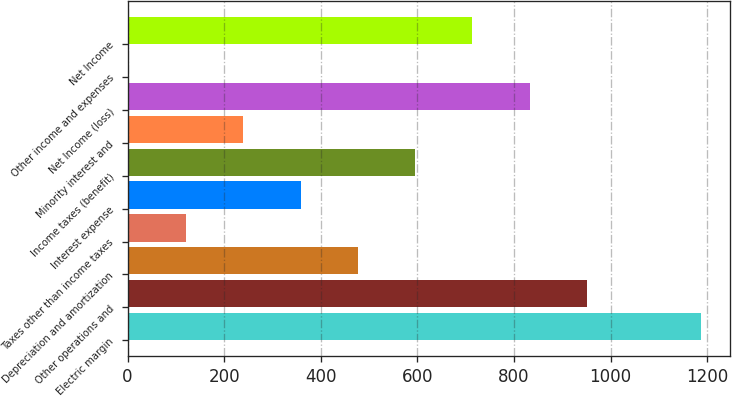Convert chart to OTSL. <chart><loc_0><loc_0><loc_500><loc_500><bar_chart><fcel>Electric margin<fcel>Other operations and<fcel>Depreciation and amortization<fcel>Taxes other than income taxes<fcel>Interest expense<fcel>Income taxes (benefit)<fcel>Minority interest and<fcel>Net Income (loss)<fcel>Other income and expenses<fcel>Net Income<nl><fcel>1188<fcel>951<fcel>477<fcel>121.5<fcel>358.5<fcel>595.5<fcel>240<fcel>832.5<fcel>3<fcel>714<nl></chart> 